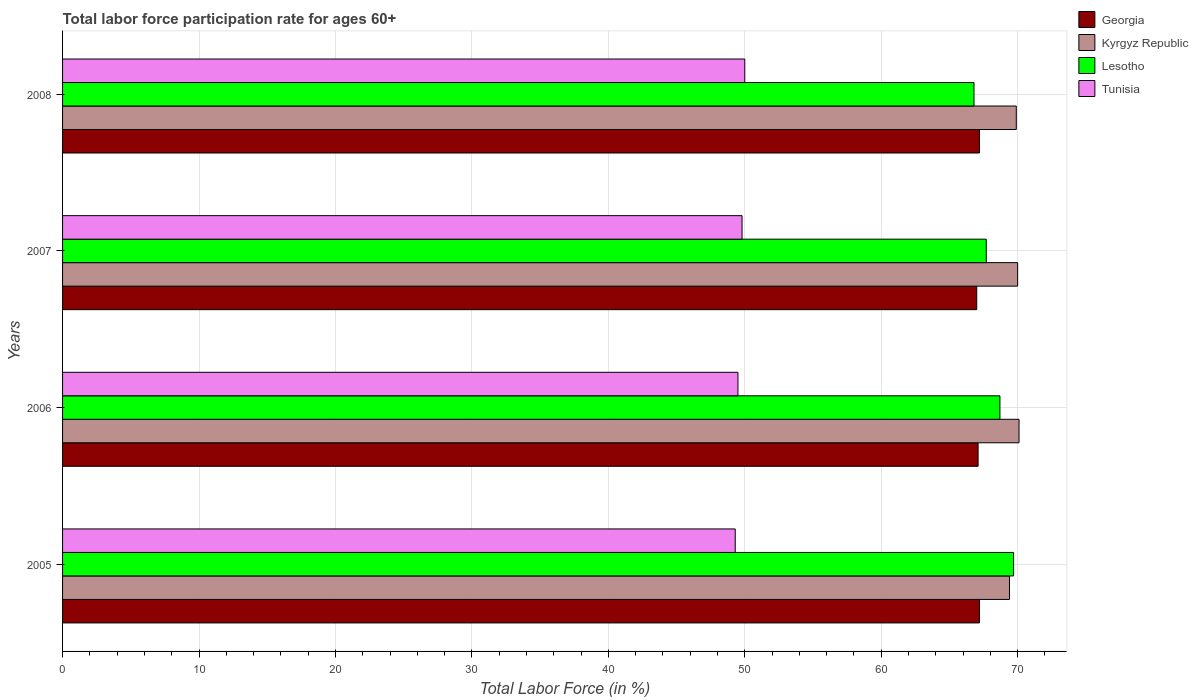How many groups of bars are there?
Offer a very short reply. 4. What is the label of the 2nd group of bars from the top?
Make the answer very short. 2007. In how many cases, is the number of bars for a given year not equal to the number of legend labels?
Give a very brief answer. 0. What is the labor force participation rate in Kyrgyz Republic in 2006?
Make the answer very short. 70.1. Across all years, what is the maximum labor force participation rate in Lesotho?
Offer a terse response. 69.7. Across all years, what is the minimum labor force participation rate in Tunisia?
Your answer should be compact. 49.3. What is the total labor force participation rate in Georgia in the graph?
Your answer should be very brief. 268.5. What is the difference between the labor force participation rate in Lesotho in 2005 and that in 2006?
Give a very brief answer. 1. What is the difference between the labor force participation rate in Kyrgyz Republic in 2005 and the labor force participation rate in Lesotho in 2007?
Your answer should be compact. 1.7. What is the average labor force participation rate in Tunisia per year?
Your response must be concise. 49.65. In the year 2007, what is the difference between the labor force participation rate in Lesotho and labor force participation rate in Tunisia?
Your answer should be compact. 17.9. In how many years, is the labor force participation rate in Tunisia greater than 20 %?
Ensure brevity in your answer.  4. What is the ratio of the labor force participation rate in Lesotho in 2005 to that in 2007?
Offer a terse response. 1.03. Is the difference between the labor force participation rate in Lesotho in 2006 and 2007 greater than the difference between the labor force participation rate in Tunisia in 2006 and 2007?
Ensure brevity in your answer.  Yes. What is the difference between the highest and the lowest labor force participation rate in Kyrgyz Republic?
Give a very brief answer. 0.7. In how many years, is the labor force participation rate in Georgia greater than the average labor force participation rate in Georgia taken over all years?
Offer a terse response. 2. What does the 3rd bar from the top in 2008 represents?
Ensure brevity in your answer.  Kyrgyz Republic. What does the 1st bar from the bottom in 2005 represents?
Keep it short and to the point. Georgia. Is it the case that in every year, the sum of the labor force participation rate in Lesotho and labor force participation rate in Tunisia is greater than the labor force participation rate in Kyrgyz Republic?
Make the answer very short. Yes. Are all the bars in the graph horizontal?
Your answer should be very brief. Yes. How many years are there in the graph?
Ensure brevity in your answer.  4. Are the values on the major ticks of X-axis written in scientific E-notation?
Provide a succinct answer. No. Does the graph contain any zero values?
Your answer should be compact. No. Where does the legend appear in the graph?
Make the answer very short. Top right. How many legend labels are there?
Offer a terse response. 4. What is the title of the graph?
Keep it short and to the point. Total labor force participation rate for ages 60+. Does "Montenegro" appear as one of the legend labels in the graph?
Offer a terse response. No. What is the label or title of the Y-axis?
Offer a terse response. Years. What is the Total Labor Force (in %) in Georgia in 2005?
Your response must be concise. 67.2. What is the Total Labor Force (in %) of Kyrgyz Republic in 2005?
Ensure brevity in your answer.  69.4. What is the Total Labor Force (in %) of Lesotho in 2005?
Give a very brief answer. 69.7. What is the Total Labor Force (in %) in Tunisia in 2005?
Offer a terse response. 49.3. What is the Total Labor Force (in %) in Georgia in 2006?
Your answer should be compact. 67.1. What is the Total Labor Force (in %) in Kyrgyz Republic in 2006?
Ensure brevity in your answer.  70.1. What is the Total Labor Force (in %) of Lesotho in 2006?
Provide a short and direct response. 68.7. What is the Total Labor Force (in %) of Tunisia in 2006?
Offer a very short reply. 49.5. What is the Total Labor Force (in %) of Georgia in 2007?
Your response must be concise. 67. What is the Total Labor Force (in %) of Lesotho in 2007?
Provide a succinct answer. 67.7. What is the Total Labor Force (in %) of Tunisia in 2007?
Ensure brevity in your answer.  49.8. What is the Total Labor Force (in %) in Georgia in 2008?
Offer a terse response. 67.2. What is the Total Labor Force (in %) of Kyrgyz Republic in 2008?
Your response must be concise. 69.9. What is the Total Labor Force (in %) of Lesotho in 2008?
Provide a succinct answer. 66.8. Across all years, what is the maximum Total Labor Force (in %) of Georgia?
Keep it short and to the point. 67.2. Across all years, what is the maximum Total Labor Force (in %) in Kyrgyz Republic?
Offer a very short reply. 70.1. Across all years, what is the maximum Total Labor Force (in %) in Lesotho?
Provide a short and direct response. 69.7. Across all years, what is the maximum Total Labor Force (in %) of Tunisia?
Provide a succinct answer. 50. Across all years, what is the minimum Total Labor Force (in %) of Kyrgyz Republic?
Provide a short and direct response. 69.4. Across all years, what is the minimum Total Labor Force (in %) in Lesotho?
Your answer should be very brief. 66.8. Across all years, what is the minimum Total Labor Force (in %) of Tunisia?
Your answer should be very brief. 49.3. What is the total Total Labor Force (in %) of Georgia in the graph?
Offer a very short reply. 268.5. What is the total Total Labor Force (in %) in Kyrgyz Republic in the graph?
Provide a succinct answer. 279.4. What is the total Total Labor Force (in %) of Lesotho in the graph?
Provide a succinct answer. 272.9. What is the total Total Labor Force (in %) of Tunisia in the graph?
Offer a terse response. 198.6. What is the difference between the Total Labor Force (in %) of Lesotho in 2005 and that in 2006?
Your answer should be very brief. 1. What is the difference between the Total Labor Force (in %) in Georgia in 2005 and that in 2007?
Offer a terse response. 0.2. What is the difference between the Total Labor Force (in %) in Kyrgyz Republic in 2005 and that in 2007?
Your response must be concise. -0.6. What is the difference between the Total Labor Force (in %) of Lesotho in 2005 and that in 2007?
Provide a succinct answer. 2. What is the difference between the Total Labor Force (in %) of Kyrgyz Republic in 2005 and that in 2008?
Offer a very short reply. -0.5. What is the difference between the Total Labor Force (in %) of Lesotho in 2005 and that in 2008?
Make the answer very short. 2.9. What is the difference between the Total Labor Force (in %) in Georgia in 2006 and that in 2007?
Offer a terse response. 0.1. What is the difference between the Total Labor Force (in %) in Tunisia in 2006 and that in 2007?
Provide a succinct answer. -0.3. What is the difference between the Total Labor Force (in %) in Georgia in 2006 and that in 2008?
Ensure brevity in your answer.  -0.1. What is the difference between the Total Labor Force (in %) in Kyrgyz Republic in 2006 and that in 2008?
Your answer should be very brief. 0.2. What is the difference between the Total Labor Force (in %) of Kyrgyz Republic in 2007 and that in 2008?
Offer a very short reply. 0.1. What is the difference between the Total Labor Force (in %) in Lesotho in 2005 and the Total Labor Force (in %) in Tunisia in 2006?
Your response must be concise. 20.2. What is the difference between the Total Labor Force (in %) of Georgia in 2005 and the Total Labor Force (in %) of Lesotho in 2007?
Make the answer very short. -0.5. What is the difference between the Total Labor Force (in %) of Georgia in 2005 and the Total Labor Force (in %) of Tunisia in 2007?
Your response must be concise. 17.4. What is the difference between the Total Labor Force (in %) in Kyrgyz Republic in 2005 and the Total Labor Force (in %) in Lesotho in 2007?
Provide a short and direct response. 1.7. What is the difference between the Total Labor Force (in %) of Kyrgyz Republic in 2005 and the Total Labor Force (in %) of Tunisia in 2007?
Make the answer very short. 19.6. What is the difference between the Total Labor Force (in %) of Georgia in 2005 and the Total Labor Force (in %) of Lesotho in 2008?
Make the answer very short. 0.4. What is the difference between the Total Labor Force (in %) of Georgia in 2005 and the Total Labor Force (in %) of Tunisia in 2008?
Provide a succinct answer. 17.2. What is the difference between the Total Labor Force (in %) in Kyrgyz Republic in 2005 and the Total Labor Force (in %) in Lesotho in 2008?
Offer a terse response. 2.6. What is the difference between the Total Labor Force (in %) in Kyrgyz Republic in 2005 and the Total Labor Force (in %) in Tunisia in 2008?
Ensure brevity in your answer.  19.4. What is the difference between the Total Labor Force (in %) of Lesotho in 2005 and the Total Labor Force (in %) of Tunisia in 2008?
Give a very brief answer. 19.7. What is the difference between the Total Labor Force (in %) of Georgia in 2006 and the Total Labor Force (in %) of Lesotho in 2007?
Ensure brevity in your answer.  -0.6. What is the difference between the Total Labor Force (in %) of Georgia in 2006 and the Total Labor Force (in %) of Tunisia in 2007?
Provide a succinct answer. 17.3. What is the difference between the Total Labor Force (in %) of Kyrgyz Republic in 2006 and the Total Labor Force (in %) of Tunisia in 2007?
Provide a short and direct response. 20.3. What is the difference between the Total Labor Force (in %) in Georgia in 2006 and the Total Labor Force (in %) in Lesotho in 2008?
Make the answer very short. 0.3. What is the difference between the Total Labor Force (in %) of Kyrgyz Republic in 2006 and the Total Labor Force (in %) of Tunisia in 2008?
Keep it short and to the point. 20.1. What is the difference between the Total Labor Force (in %) of Lesotho in 2006 and the Total Labor Force (in %) of Tunisia in 2008?
Give a very brief answer. 18.7. What is the difference between the Total Labor Force (in %) in Georgia in 2007 and the Total Labor Force (in %) in Tunisia in 2008?
Give a very brief answer. 17. What is the difference between the Total Labor Force (in %) in Kyrgyz Republic in 2007 and the Total Labor Force (in %) in Lesotho in 2008?
Your answer should be very brief. 3.2. What is the average Total Labor Force (in %) of Georgia per year?
Offer a very short reply. 67.12. What is the average Total Labor Force (in %) in Kyrgyz Republic per year?
Your answer should be very brief. 69.85. What is the average Total Labor Force (in %) in Lesotho per year?
Offer a terse response. 68.22. What is the average Total Labor Force (in %) in Tunisia per year?
Ensure brevity in your answer.  49.65. In the year 2005, what is the difference between the Total Labor Force (in %) of Georgia and Total Labor Force (in %) of Kyrgyz Republic?
Your response must be concise. -2.2. In the year 2005, what is the difference between the Total Labor Force (in %) in Kyrgyz Republic and Total Labor Force (in %) in Tunisia?
Ensure brevity in your answer.  20.1. In the year 2005, what is the difference between the Total Labor Force (in %) in Lesotho and Total Labor Force (in %) in Tunisia?
Offer a terse response. 20.4. In the year 2006, what is the difference between the Total Labor Force (in %) of Georgia and Total Labor Force (in %) of Kyrgyz Republic?
Your response must be concise. -3. In the year 2006, what is the difference between the Total Labor Force (in %) in Georgia and Total Labor Force (in %) in Tunisia?
Your answer should be very brief. 17.6. In the year 2006, what is the difference between the Total Labor Force (in %) of Kyrgyz Republic and Total Labor Force (in %) of Lesotho?
Offer a very short reply. 1.4. In the year 2006, what is the difference between the Total Labor Force (in %) of Kyrgyz Republic and Total Labor Force (in %) of Tunisia?
Give a very brief answer. 20.6. In the year 2006, what is the difference between the Total Labor Force (in %) of Lesotho and Total Labor Force (in %) of Tunisia?
Offer a terse response. 19.2. In the year 2007, what is the difference between the Total Labor Force (in %) in Georgia and Total Labor Force (in %) in Kyrgyz Republic?
Give a very brief answer. -3. In the year 2007, what is the difference between the Total Labor Force (in %) in Georgia and Total Labor Force (in %) in Lesotho?
Your response must be concise. -0.7. In the year 2007, what is the difference between the Total Labor Force (in %) in Kyrgyz Republic and Total Labor Force (in %) in Lesotho?
Keep it short and to the point. 2.3. In the year 2007, what is the difference between the Total Labor Force (in %) in Kyrgyz Republic and Total Labor Force (in %) in Tunisia?
Provide a succinct answer. 20.2. In the year 2007, what is the difference between the Total Labor Force (in %) of Lesotho and Total Labor Force (in %) of Tunisia?
Your answer should be compact. 17.9. In the year 2008, what is the difference between the Total Labor Force (in %) of Georgia and Total Labor Force (in %) of Lesotho?
Your answer should be compact. 0.4. In the year 2008, what is the difference between the Total Labor Force (in %) of Kyrgyz Republic and Total Labor Force (in %) of Lesotho?
Offer a very short reply. 3.1. In the year 2008, what is the difference between the Total Labor Force (in %) of Kyrgyz Republic and Total Labor Force (in %) of Tunisia?
Offer a terse response. 19.9. What is the ratio of the Total Labor Force (in %) in Kyrgyz Republic in 2005 to that in 2006?
Provide a succinct answer. 0.99. What is the ratio of the Total Labor Force (in %) of Lesotho in 2005 to that in 2006?
Offer a terse response. 1.01. What is the ratio of the Total Labor Force (in %) in Tunisia in 2005 to that in 2006?
Ensure brevity in your answer.  1. What is the ratio of the Total Labor Force (in %) of Kyrgyz Republic in 2005 to that in 2007?
Offer a terse response. 0.99. What is the ratio of the Total Labor Force (in %) of Lesotho in 2005 to that in 2007?
Ensure brevity in your answer.  1.03. What is the ratio of the Total Labor Force (in %) in Lesotho in 2005 to that in 2008?
Offer a terse response. 1.04. What is the ratio of the Total Labor Force (in %) in Georgia in 2006 to that in 2007?
Provide a short and direct response. 1. What is the ratio of the Total Labor Force (in %) of Lesotho in 2006 to that in 2007?
Provide a short and direct response. 1.01. What is the ratio of the Total Labor Force (in %) in Tunisia in 2006 to that in 2007?
Keep it short and to the point. 0.99. What is the ratio of the Total Labor Force (in %) of Lesotho in 2006 to that in 2008?
Your response must be concise. 1.03. What is the ratio of the Total Labor Force (in %) in Kyrgyz Republic in 2007 to that in 2008?
Ensure brevity in your answer.  1. What is the ratio of the Total Labor Force (in %) in Lesotho in 2007 to that in 2008?
Keep it short and to the point. 1.01. What is the ratio of the Total Labor Force (in %) of Tunisia in 2007 to that in 2008?
Keep it short and to the point. 1. What is the difference between the highest and the second highest Total Labor Force (in %) of Georgia?
Offer a very short reply. 0. What is the difference between the highest and the second highest Total Labor Force (in %) of Kyrgyz Republic?
Provide a succinct answer. 0.1. What is the difference between the highest and the lowest Total Labor Force (in %) in Tunisia?
Your answer should be compact. 0.7. 